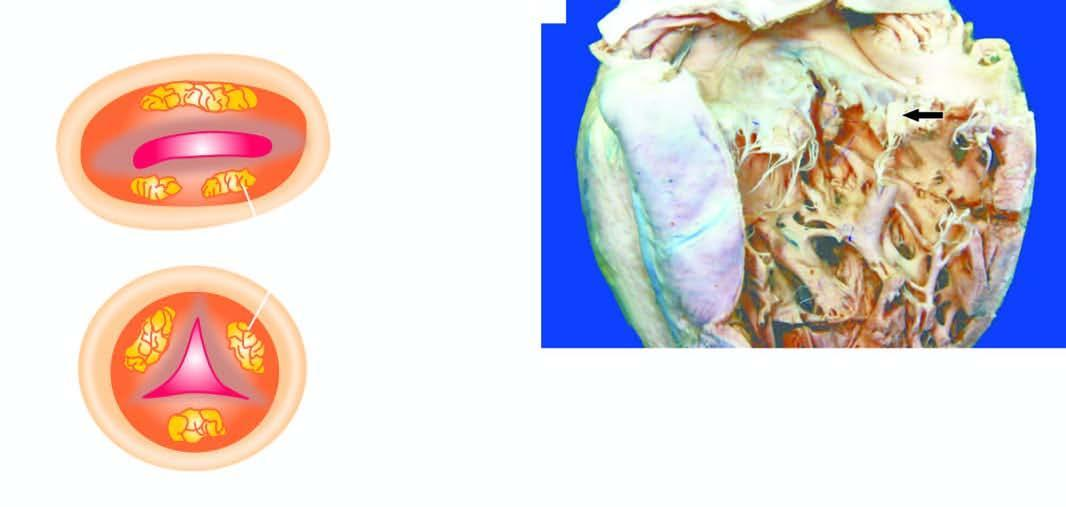what are the vegetations shown on?
Answer the question using a single word or phrase. Mitral valve 